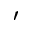<formula> <loc_0><loc_0><loc_500><loc_500>^ { \prime }</formula> 